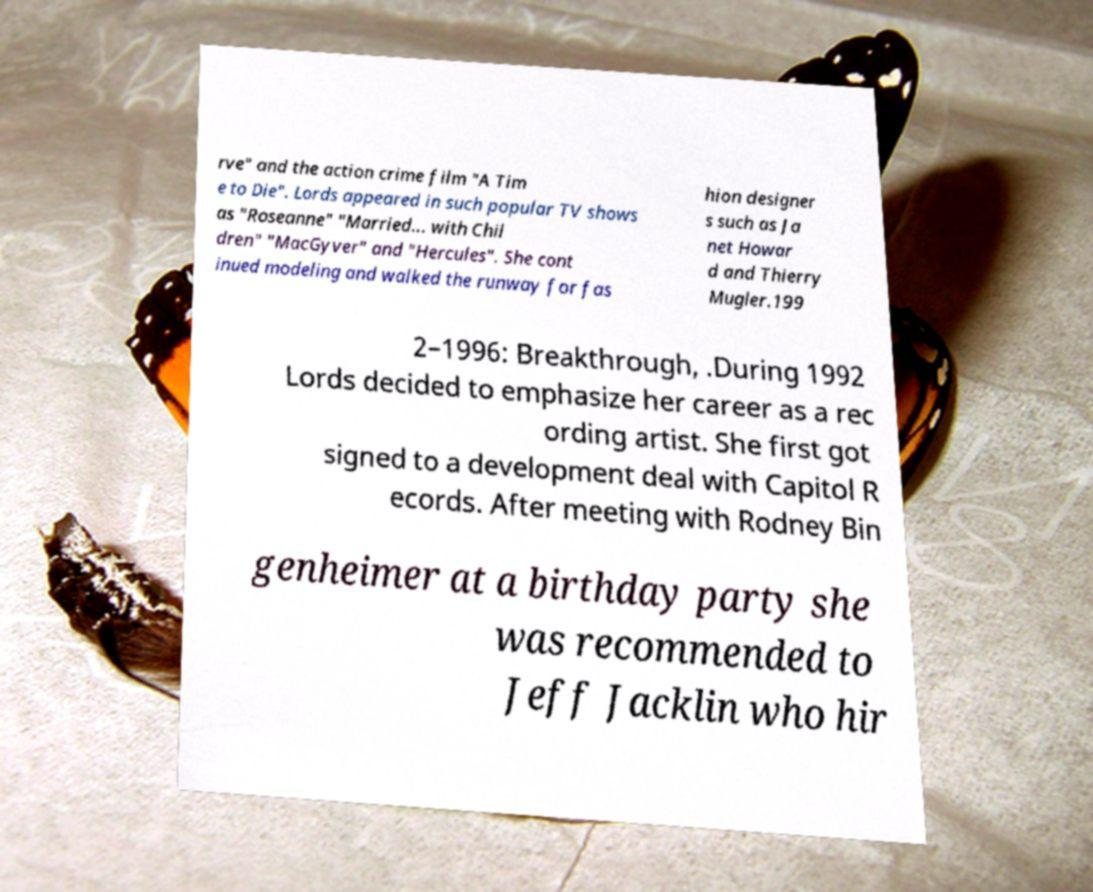I need the written content from this picture converted into text. Can you do that? rve" and the action crime film "A Tim e to Die". Lords appeared in such popular TV shows as "Roseanne" "Married... with Chil dren" "MacGyver" and "Hercules". She cont inued modeling and walked the runway for fas hion designer s such as Ja net Howar d and Thierry Mugler.199 2–1996: Breakthrough, .During 1992 Lords decided to emphasize her career as a rec ording artist. She first got signed to a development deal with Capitol R ecords. After meeting with Rodney Bin genheimer at a birthday party she was recommended to Jeff Jacklin who hir 